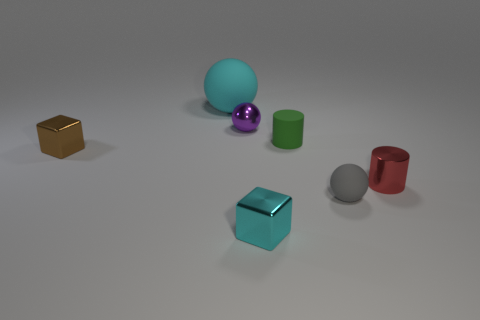What is the shape of the small metallic object that is the same color as the big object?
Provide a short and direct response. Cube. Is there anything else that is the same color as the tiny shiny cylinder?
Your response must be concise. No. What number of objects are rubber balls behind the cyan metal block or tiny spheres that are left of the tiny cyan thing?
Provide a succinct answer. 3. The metallic object that is left of the cyan cube and to the right of the brown metallic block has what shape?
Make the answer very short. Sphere. There is a tiny matte object that is left of the gray object; what number of tiny cyan cubes are behind it?
Your answer should be very brief. 0. Is there any other thing that is made of the same material as the purple thing?
Provide a succinct answer. Yes. How many things are either blocks that are in front of the red cylinder or blue rubber blocks?
Your answer should be very brief. 1. There is a ball left of the purple object; what is its size?
Provide a short and direct response. Large. What is the tiny purple thing made of?
Your answer should be very brief. Metal. The small rubber object that is behind the small block behind the gray sphere is what shape?
Your answer should be compact. Cylinder. 